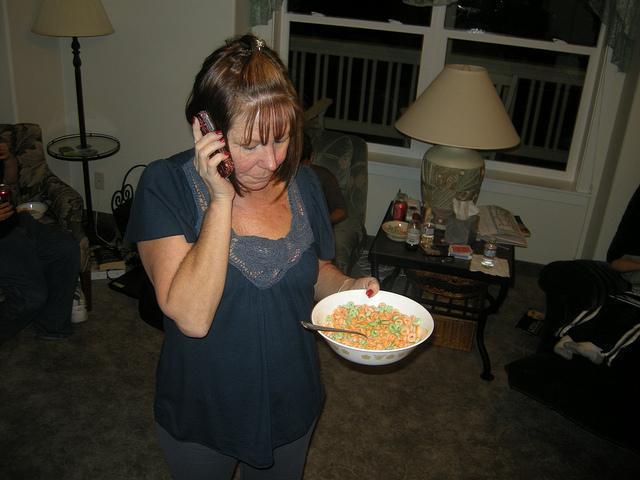What age group normally eats this food?
Select the accurate answer and provide explanation: 'Answer: answer
Rationale: rationale.'
Options: Young adults, teenagers, kids, seniors. Answer: kids.
Rationale: The food is cereal based on the shape and coloring and it's serving method. this food type is commonly associated with answer a. 